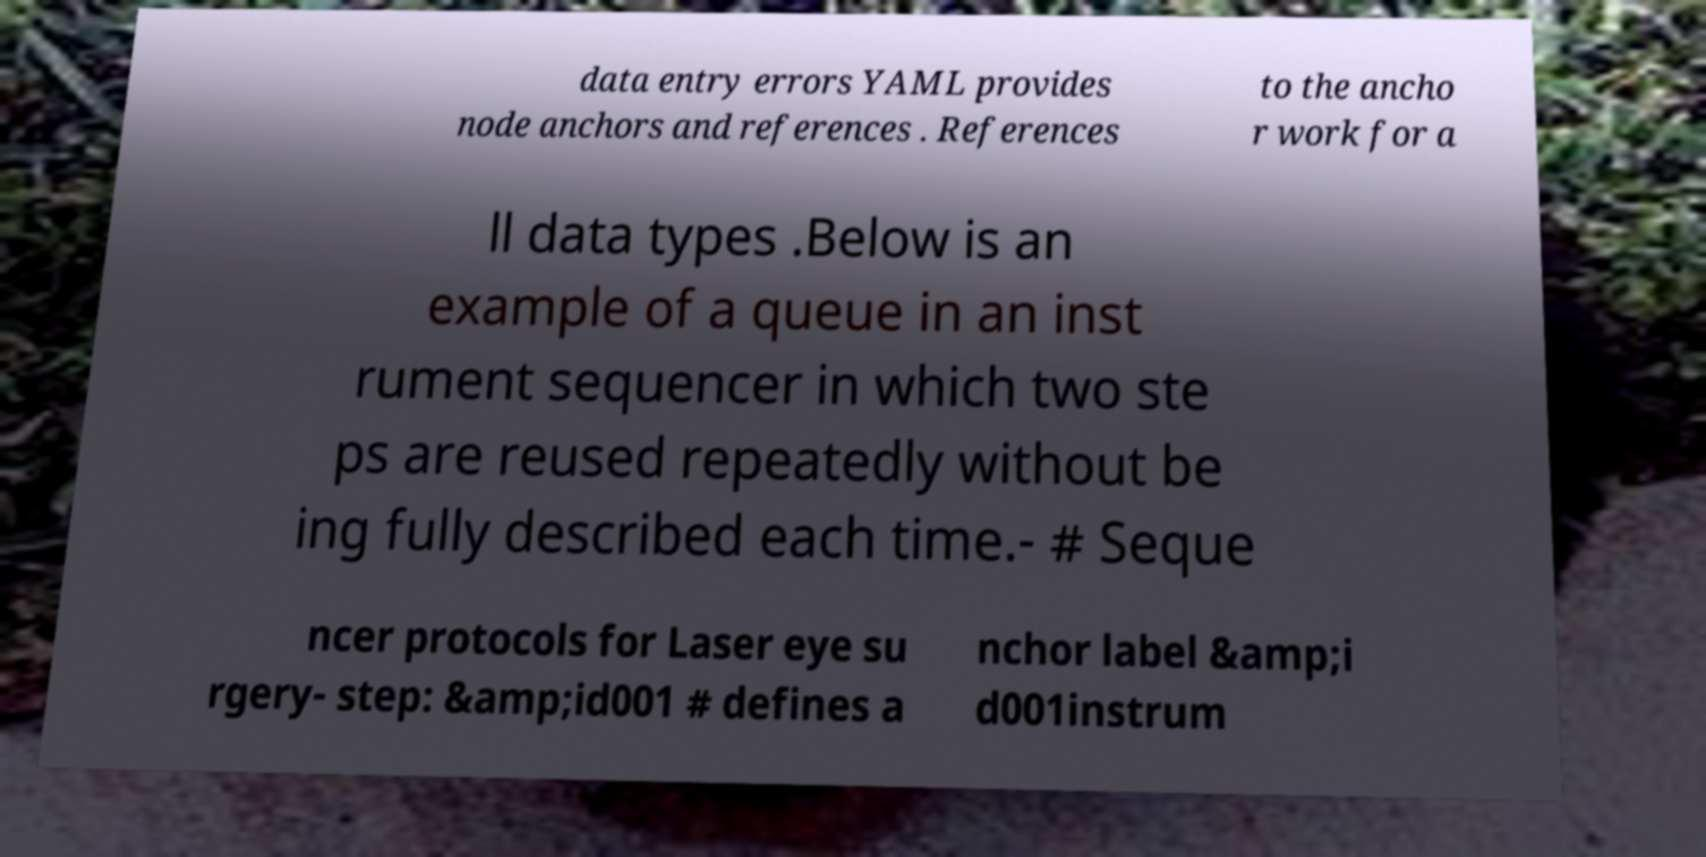There's text embedded in this image that I need extracted. Can you transcribe it verbatim? data entry errors YAML provides node anchors and references . References to the ancho r work for a ll data types .Below is an example of a queue in an inst rument sequencer in which two ste ps are reused repeatedly without be ing fully described each time.- # Seque ncer protocols for Laser eye su rgery- step: &amp;id001 # defines a nchor label &amp;i d001instrum 